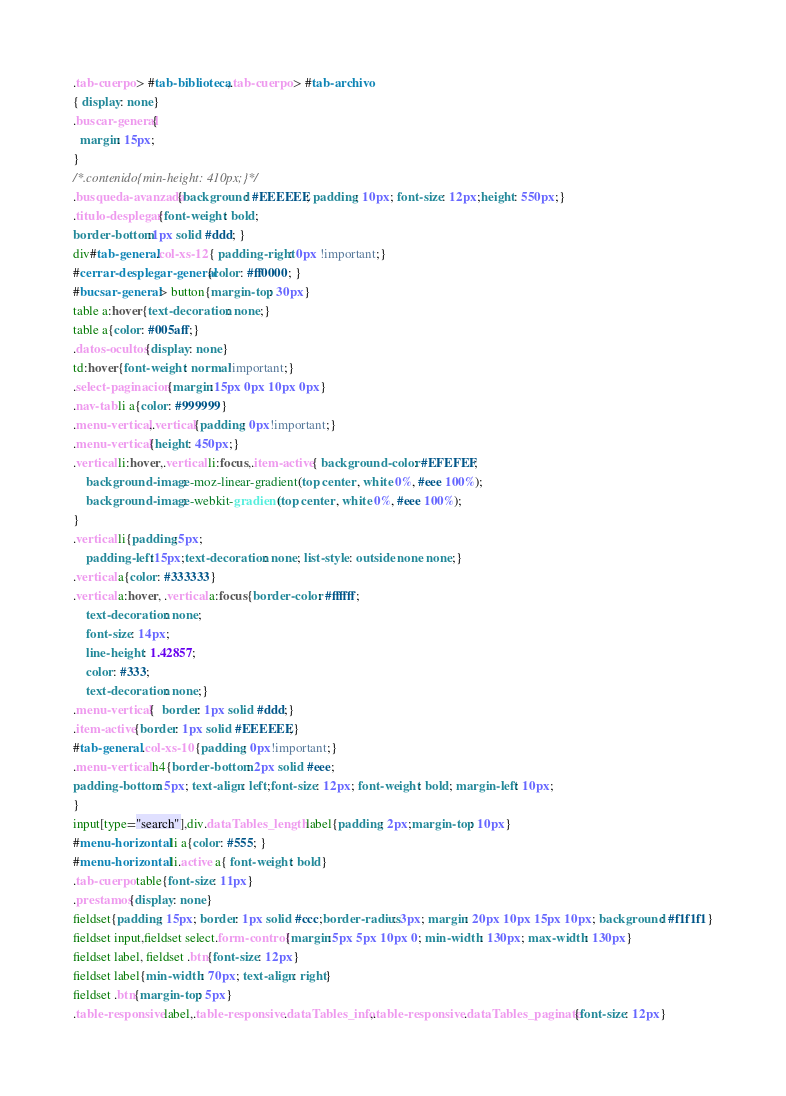Convert code to text. <code><loc_0><loc_0><loc_500><loc_500><_CSS_>.tab-cuerpo > #tab-biblioteca,.tab-cuerpo > #tab-archivo
{ display: none}
.buscar-general{
  margin: 15px;
}
/*.contenido{min-height: 410px;}*/
.busqueda-avanzada{background: #EEEEEE; padding: 10px; font-size: 12px;height: 550px;}
.titulo-desplegar{font-weight: bold;
border-bottom:1px solid #ddd; }
div#tab-general.col-xs-12{ padding-right: 0px !important;}
#cerrar-desplegar-general{color: #ff0000; }
#bucsar-general > button{margin-top: 30px}
table a:hover{text-decoration: none;}
table a{color: #005aff;}
.datos-ocultos{display: none}
td:hover{font-weight: normal!important;}
.select-paginacion{margin:15px 0px 10px 0px}
.nav-tab li a{color: #999999}
.menu-vertical,.vertical{padding: 0px!important;}
.menu-vertical{height: 450px;}
.vertical li:hover,.vertical li:focus,.item-active{ background-color: #EFEFEF;
    background-image: -moz-linear-gradient(top center , white 0%, #eee 100%);
    background-image: -webkit-gradient(top center , white 0%, #eee 100%);
}
.vertical li{padding:5px;
    padding-left:15px;text-decoration: none; list-style: outside none none;}
.vertical a{color: #333333}
.vertical a:hover, .vertical a:focus{border-color: #ffffff;
    text-decoration: none;
    font-size: 14px;
    line-height: 1.42857;
    color: #333;
    text-decoration: none;}
.menu-vertical{  border: 1px solid #ddd;}
.item-active{border: 1px solid #EEEEEE;}
#tab-general .col-xs-10{padding: 0px!important;}
.menu-vertical h4{border-bottom: 2px solid #eee;
padding-bottom: 5px; text-align: left;font-size: 12px; font-weight: bold; margin-left: 10px;
}
input[type="search"],div.dataTables_length label{padding: 2px;margin-top: 10px}
#menu-horizontal li a{color: #555; }
#menu-horizontal li.active a{ font-weight: bold}
.tab-cuerpo table{font-size: 11px}
.prestamos{display: none}
fieldset{padding: 15px; border: 1px solid #ccc;border-radius: 3px; margin: 20px 10px 15px 10px; background: #f1f1f1}
fieldset input,fieldset select.form-control{margin:5px 5px 10px 0; min-width: 130px; max-width: 130px}
fieldset label, fieldset .btn{font-size: 12px}
fieldset label{min-width: 70px; text-align: right}
fieldset .btn{margin-top: 5px}
.table-responsive label,.table-responsive .dataTables_info,.table-responsive .dataTables_paginate{font-size: 12px}


</code> 